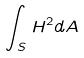<formula> <loc_0><loc_0><loc_500><loc_500>\int _ { S } H ^ { 2 } d A</formula> 